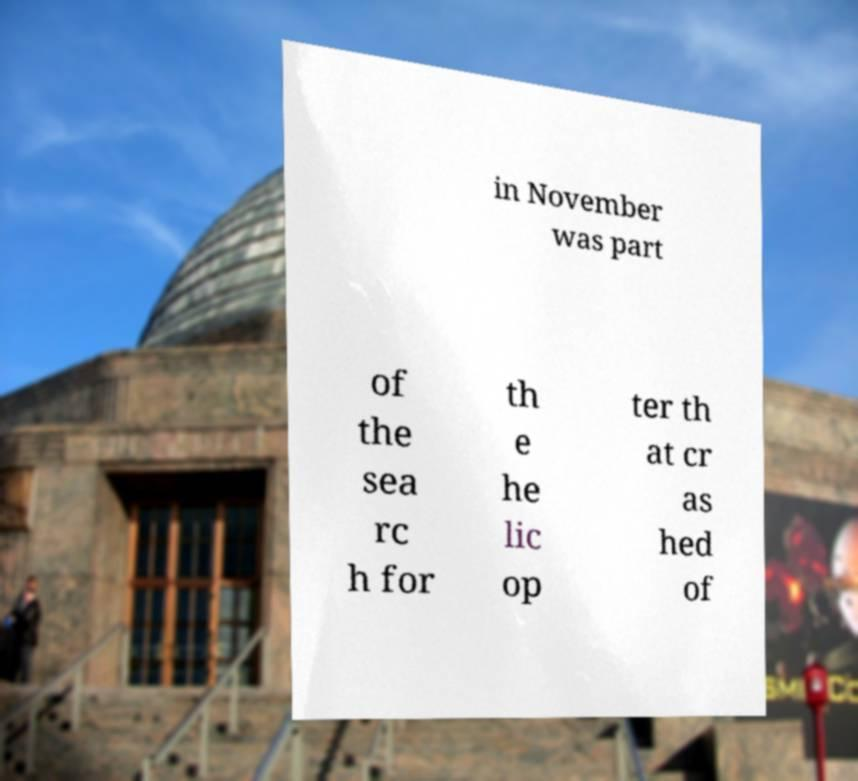What messages or text are displayed in this image? I need them in a readable, typed format. in November was part of the sea rc h for th e he lic op ter th at cr as hed of 